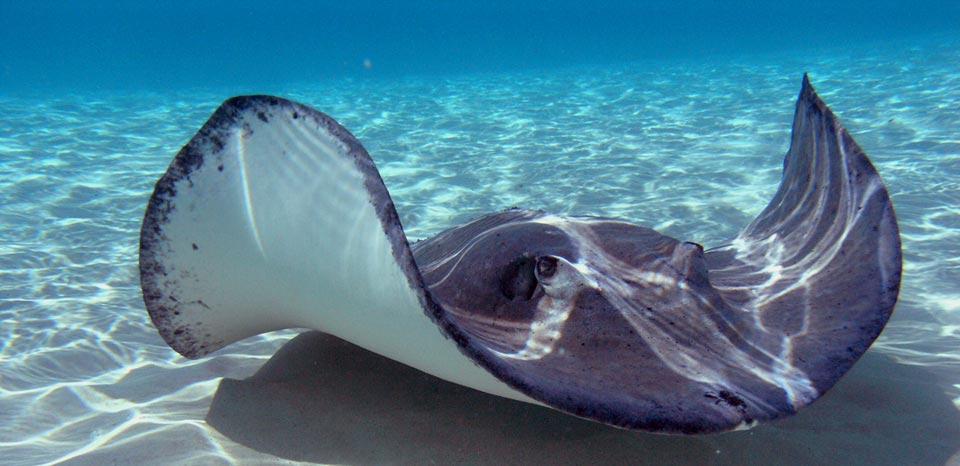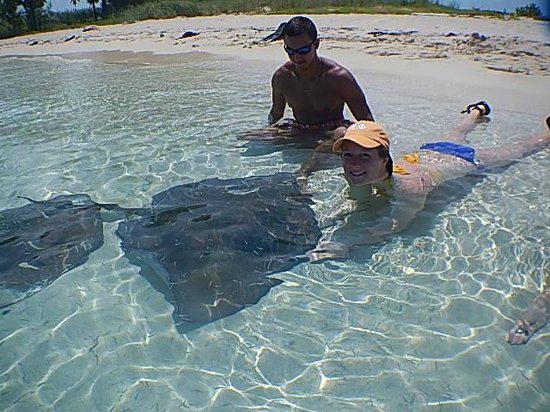The first image is the image on the left, the second image is the image on the right. For the images displayed, is the sentence "there are 3 stingrays in the image pair" factually correct? Answer yes or no. Yes. 